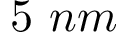Convert formula to latex. <formula><loc_0><loc_0><loc_500><loc_500>5 \ n m</formula> 